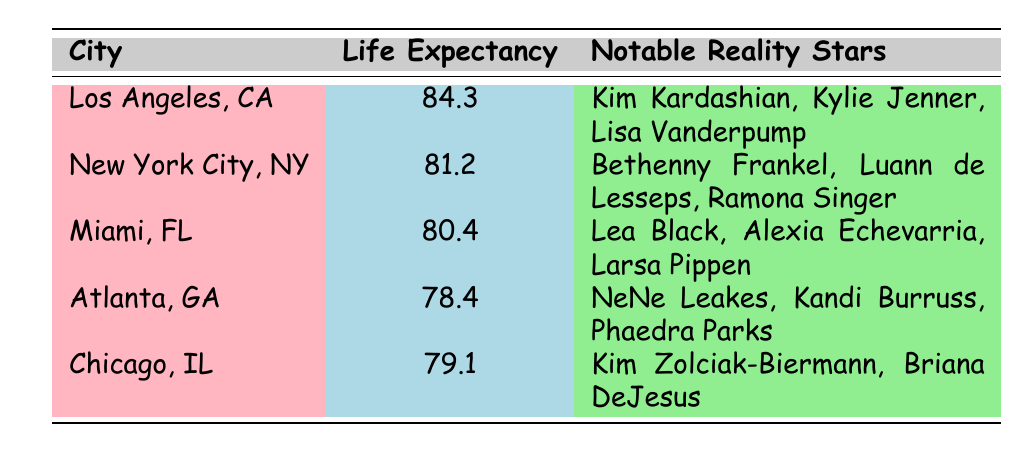What is the life expectancy in Los Angeles, CA? The table lists the average life expectancy in Los Angeles, CA, which is 84.3 years.
Answer: 84.3 Which city has the lowest life expectancy? By examining the life expectancy values in the table, Atlanta, GA, has the lowest life expectancy at 78.4 years.
Answer: Atlanta, GA What is the average life expectancy of the cities listed? To find the average, we sum the life expectancies: (84.3 + 81.2 + 80.4 + 78.4 + 79.1) = 403.4 and divide by the number of cities (5). So, 403.4 / 5 = 80.68.
Answer: 80.68 Are there any notable reality stars in Miami, FL? The table shows the notable reality stars in Miami, FL, as Lea Black, Alexia Echevarria, and Larsa Pippen. Since it lists names, this means yes.
Answer: Yes Is the average life expectancy in New York City higher than that in Chicago? The average life expectancy in New York City is 81.2 years, while Chicago’s is 79.1 years. Since 81.2 is greater than 79.1, the answer is yes.
Answer: Yes Which city has notable reality stars including Kim Kardashian and Kylie Jenner? The table identifies the notable reality stars in Los Angeles, CA, as Kim Kardashian and Kylie Jenner, matching this criteria.
Answer: Los Angeles, CA How much higher is the life expectancy in Los Angeles, CA than in Atlanta, GA? The life expectancy in Los Angeles is 84.3 years and in Atlanta is 78.4 years. The difference is 84.3 - 78.4 = 5.9 years.
Answer: 5.9 Is Lisa Vanderpump a notable reality star from New York City? The table lists notable reality stars from New York City, including Bethenny Frankel, Luann de Lesseps, and Ramona Singer. Lisa Vanderpump is not among them.
Answer: No What combined life expectancy do Miami, FL, and Atlanta, GA have? Miami’s life expectancy is 80.4, and Atlanta’s is 78.4. Adding these gives 80.4 + 78.4 = 158.8.
Answer: 158.8 